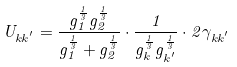<formula> <loc_0><loc_0><loc_500><loc_500>U _ { k k ^ { ^ { \prime } } } = \frac { g _ { 1 } ^ { \frac { 1 } { 3 } } g _ { 2 } ^ { \frac { 1 } { 3 } } } { g _ { 1 } ^ { \frac { 1 } { 3 } } + g _ { 2 } ^ { \frac { 1 } { 3 } } } \cdot \frac { 1 } { g _ { k } ^ { \frac { 1 } { 3 } } g _ { k ^ { ^ { \prime } } } ^ { \frac { 1 } { 3 } } } \cdot 2 \gamma _ { k k ^ { ^ { \prime } } }</formula> 